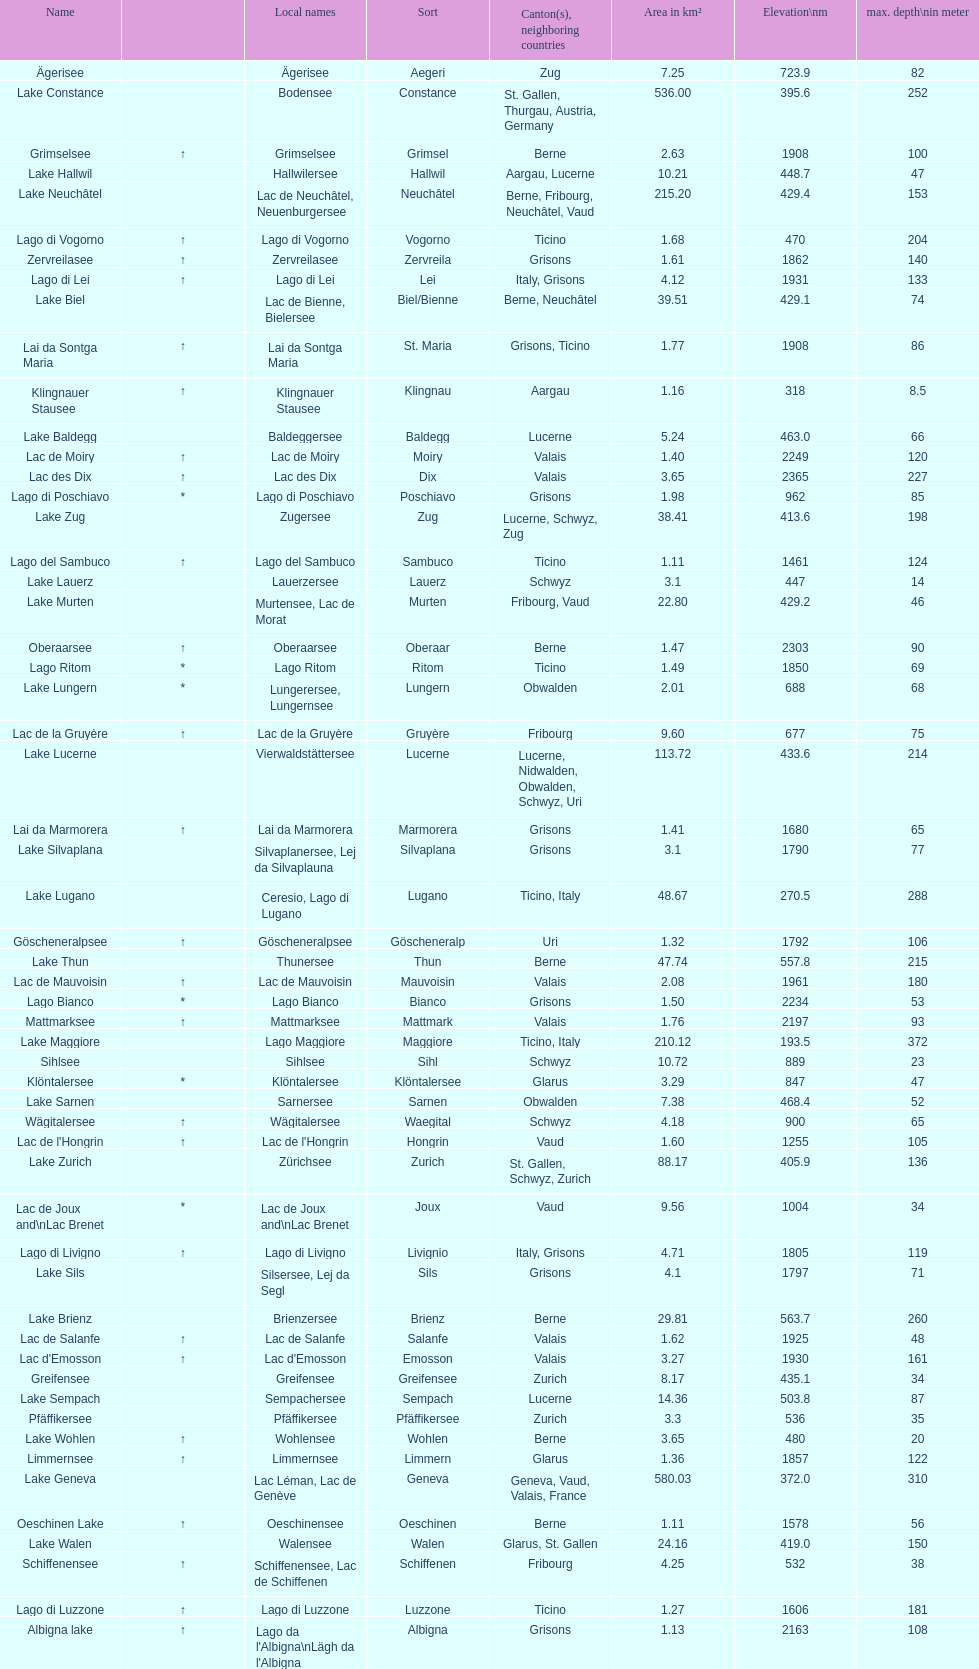What is the sum of lake sils' area measured in km²? 4.1. 